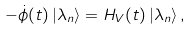<formula> <loc_0><loc_0><loc_500><loc_500>- \dot { \phi } ( t ) \left | \lambda _ { n } \right \rangle = H _ { V } ( t ) \left | \lambda _ { n } \right \rangle ,</formula> 